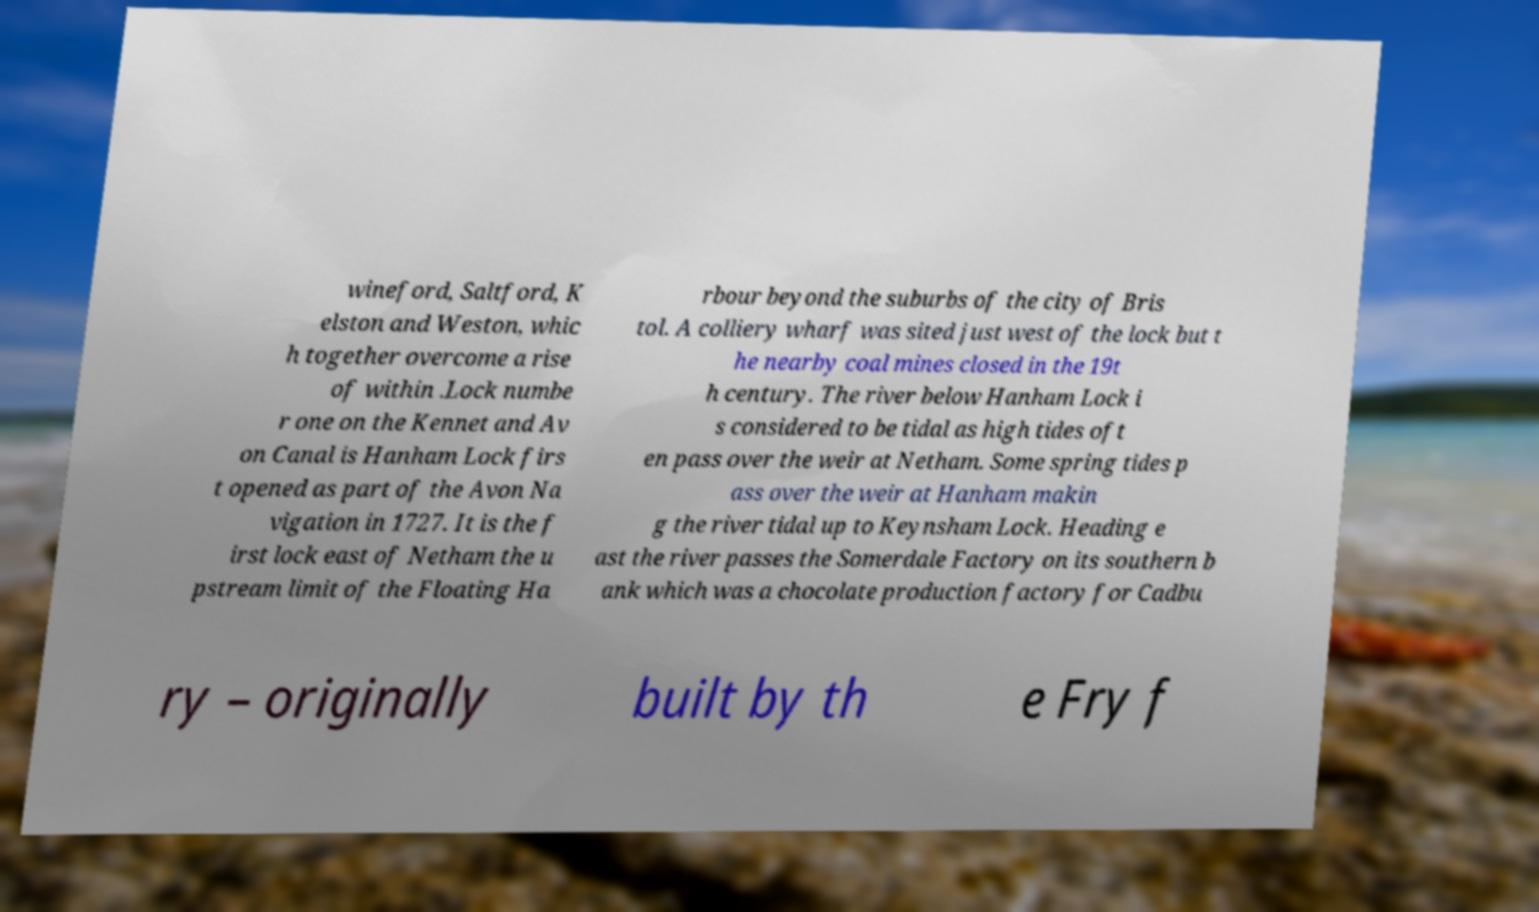Could you assist in decoding the text presented in this image and type it out clearly? wineford, Saltford, K elston and Weston, whic h together overcome a rise of within .Lock numbe r one on the Kennet and Av on Canal is Hanham Lock firs t opened as part of the Avon Na vigation in 1727. It is the f irst lock east of Netham the u pstream limit of the Floating Ha rbour beyond the suburbs of the city of Bris tol. A colliery wharf was sited just west of the lock but t he nearby coal mines closed in the 19t h century. The river below Hanham Lock i s considered to be tidal as high tides oft en pass over the weir at Netham. Some spring tides p ass over the weir at Hanham makin g the river tidal up to Keynsham Lock. Heading e ast the river passes the Somerdale Factory on its southern b ank which was a chocolate production factory for Cadbu ry – originally built by th e Fry f 